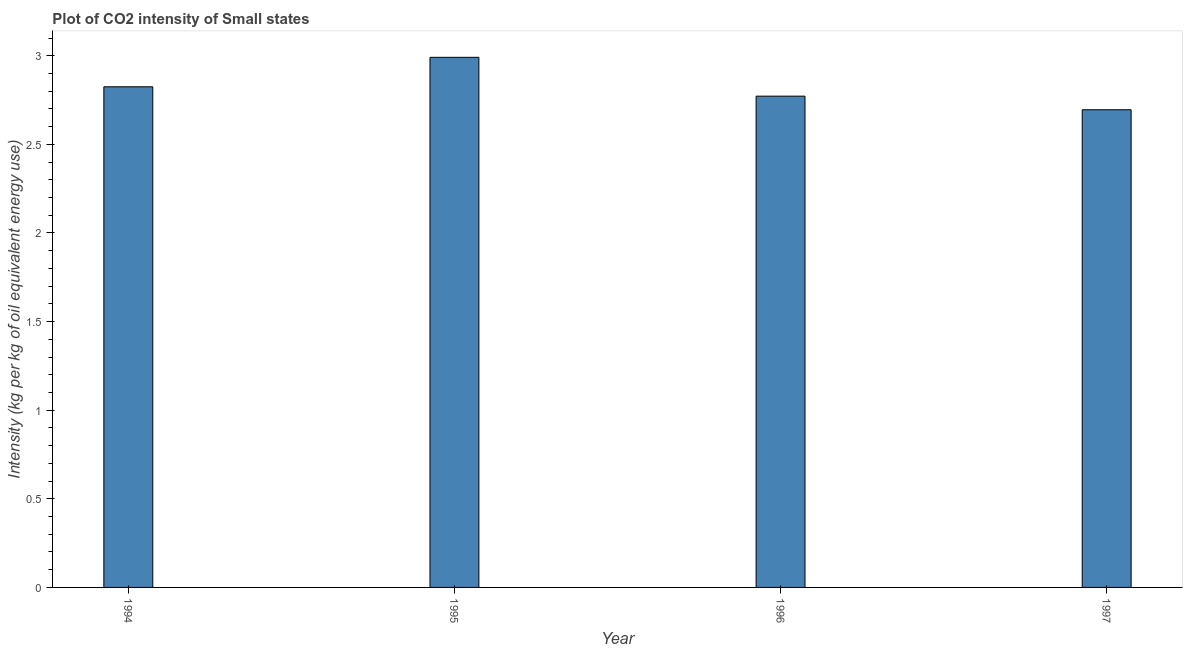What is the title of the graph?
Your answer should be compact. Plot of CO2 intensity of Small states. What is the label or title of the X-axis?
Your response must be concise. Year. What is the label or title of the Y-axis?
Your answer should be compact. Intensity (kg per kg of oil equivalent energy use). What is the co2 intensity in 1997?
Ensure brevity in your answer.  2.7. Across all years, what is the maximum co2 intensity?
Make the answer very short. 2.99. Across all years, what is the minimum co2 intensity?
Your response must be concise. 2.7. In which year was the co2 intensity minimum?
Your answer should be compact. 1997. What is the sum of the co2 intensity?
Ensure brevity in your answer.  11.28. What is the difference between the co2 intensity in 1996 and 1997?
Provide a short and direct response. 0.08. What is the average co2 intensity per year?
Ensure brevity in your answer.  2.82. What is the median co2 intensity?
Your answer should be compact. 2.8. Do a majority of the years between 1997 and 1996 (inclusive) have co2 intensity greater than 1.3 kg?
Give a very brief answer. No. Is the difference between the co2 intensity in 1994 and 1996 greater than the difference between any two years?
Keep it short and to the point. No. What is the difference between the highest and the second highest co2 intensity?
Provide a succinct answer. 0.17. Is the sum of the co2 intensity in 1995 and 1997 greater than the maximum co2 intensity across all years?
Offer a terse response. Yes. What is the difference between the highest and the lowest co2 intensity?
Provide a short and direct response. 0.3. How many years are there in the graph?
Give a very brief answer. 4. What is the Intensity (kg per kg of oil equivalent energy use) in 1994?
Offer a terse response. 2.82. What is the Intensity (kg per kg of oil equivalent energy use) in 1995?
Give a very brief answer. 2.99. What is the Intensity (kg per kg of oil equivalent energy use) in 1996?
Your response must be concise. 2.77. What is the Intensity (kg per kg of oil equivalent energy use) of 1997?
Keep it short and to the point. 2.7. What is the difference between the Intensity (kg per kg of oil equivalent energy use) in 1994 and 1995?
Make the answer very short. -0.17. What is the difference between the Intensity (kg per kg of oil equivalent energy use) in 1994 and 1996?
Give a very brief answer. 0.05. What is the difference between the Intensity (kg per kg of oil equivalent energy use) in 1994 and 1997?
Offer a terse response. 0.13. What is the difference between the Intensity (kg per kg of oil equivalent energy use) in 1995 and 1996?
Provide a short and direct response. 0.22. What is the difference between the Intensity (kg per kg of oil equivalent energy use) in 1995 and 1997?
Provide a succinct answer. 0.3. What is the difference between the Intensity (kg per kg of oil equivalent energy use) in 1996 and 1997?
Give a very brief answer. 0.08. What is the ratio of the Intensity (kg per kg of oil equivalent energy use) in 1994 to that in 1995?
Ensure brevity in your answer.  0.94. What is the ratio of the Intensity (kg per kg of oil equivalent energy use) in 1994 to that in 1996?
Give a very brief answer. 1.02. What is the ratio of the Intensity (kg per kg of oil equivalent energy use) in 1994 to that in 1997?
Your answer should be compact. 1.05. What is the ratio of the Intensity (kg per kg of oil equivalent energy use) in 1995 to that in 1996?
Provide a succinct answer. 1.08. What is the ratio of the Intensity (kg per kg of oil equivalent energy use) in 1995 to that in 1997?
Your response must be concise. 1.11. What is the ratio of the Intensity (kg per kg of oil equivalent energy use) in 1996 to that in 1997?
Keep it short and to the point. 1.03. 